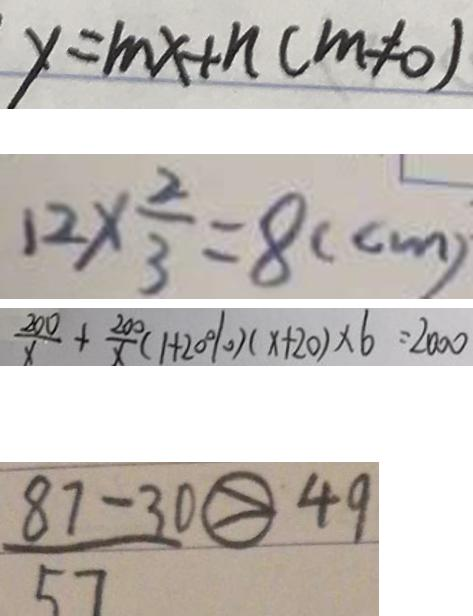<formula> <loc_0><loc_0><loc_500><loc_500>y = m x + n ( m \neq 0 ) 
 1 2 \times \frac { 2 } { 3 } = 8 ( c m ) 
 \frac { 2 0 0 } { x } + \frac { 2 0 0 } { x } ( 1 + 2 0 \% ) ( x + 2 0 ) \times 6 = 2 0 0 0 
 \frac { 8 7 - 3 0 } { 5 7 } \textcircled { > } 4 9</formula> 